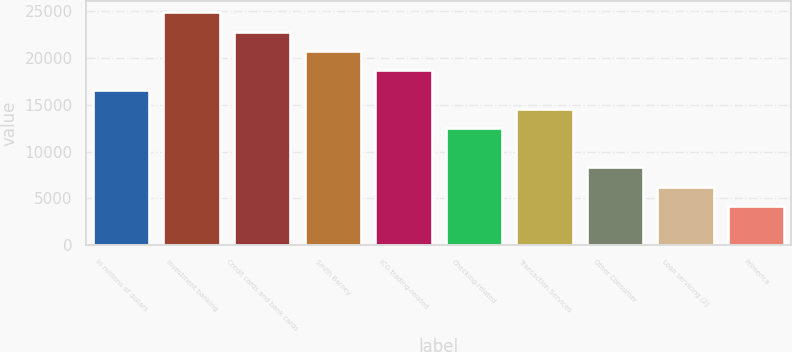<chart> <loc_0><loc_0><loc_500><loc_500><bar_chart><fcel>In millions of dollars<fcel>Investment banking<fcel>Credit cards and bank cards<fcel>Smith Barney<fcel>ICG trading-related<fcel>Checking-related<fcel>Transaction Services<fcel>Other Consumer<fcel>Loan servicing (2)<fcel>Primerica<nl><fcel>16579<fcel>24833<fcel>22769.5<fcel>20706<fcel>18642.5<fcel>12452<fcel>14515.5<fcel>8325<fcel>6261.5<fcel>4198<nl></chart> 